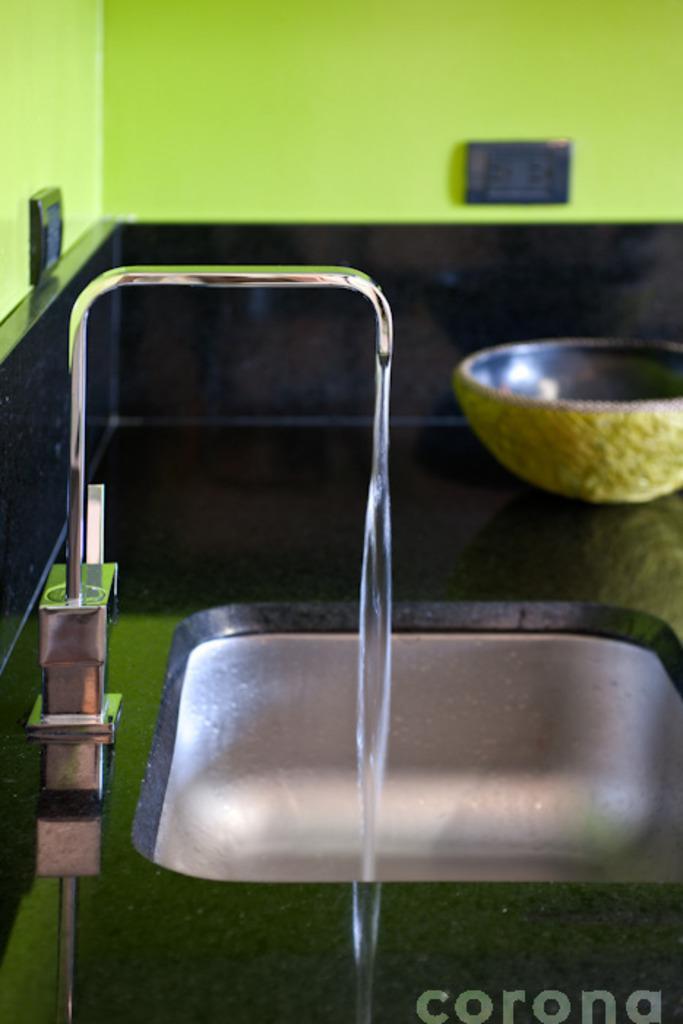Can you describe this image briefly? In this image we can see a sink with a tap and water. On the backside we can see a bowl placed aside and some switch boards on a wall. 